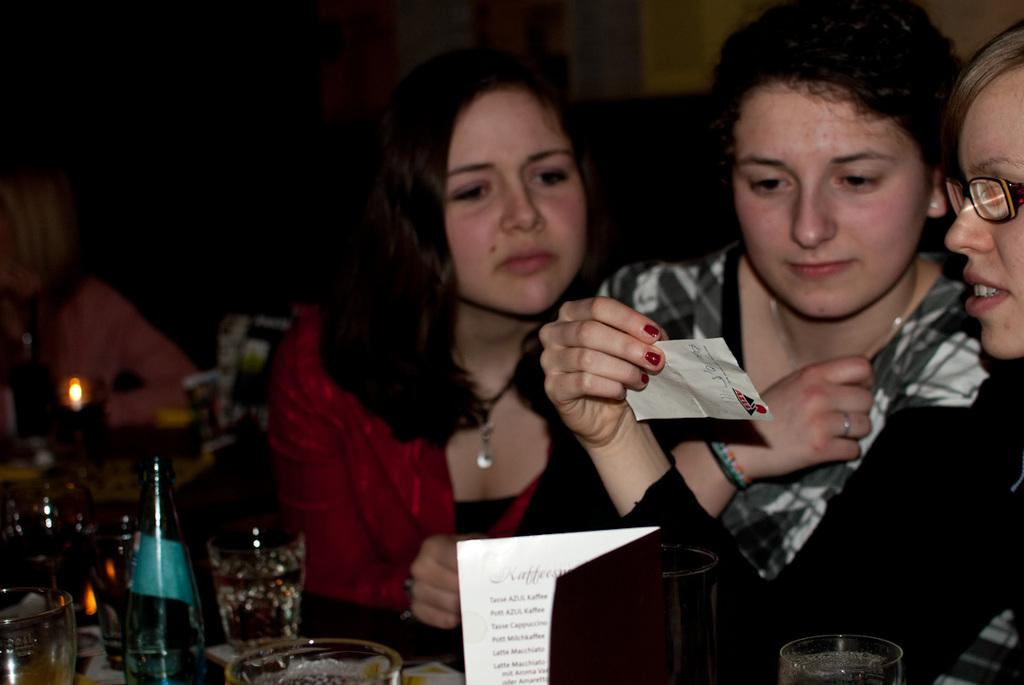What are the people in the image doing? The people in the image are sitting on chairs. What can be seen on the table in the image? There are wine glasses and a wine bottle on the table. What is the woman holding in her hand? The woman is holding a slip of paper in her hand. What shape is the parcel that is being delivered in the image? There is no parcel present in the image. 